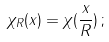<formula> <loc_0><loc_0><loc_500><loc_500>\chi _ { R } ( x ) = \chi ( \frac { x } { R } ) \, ;</formula> 